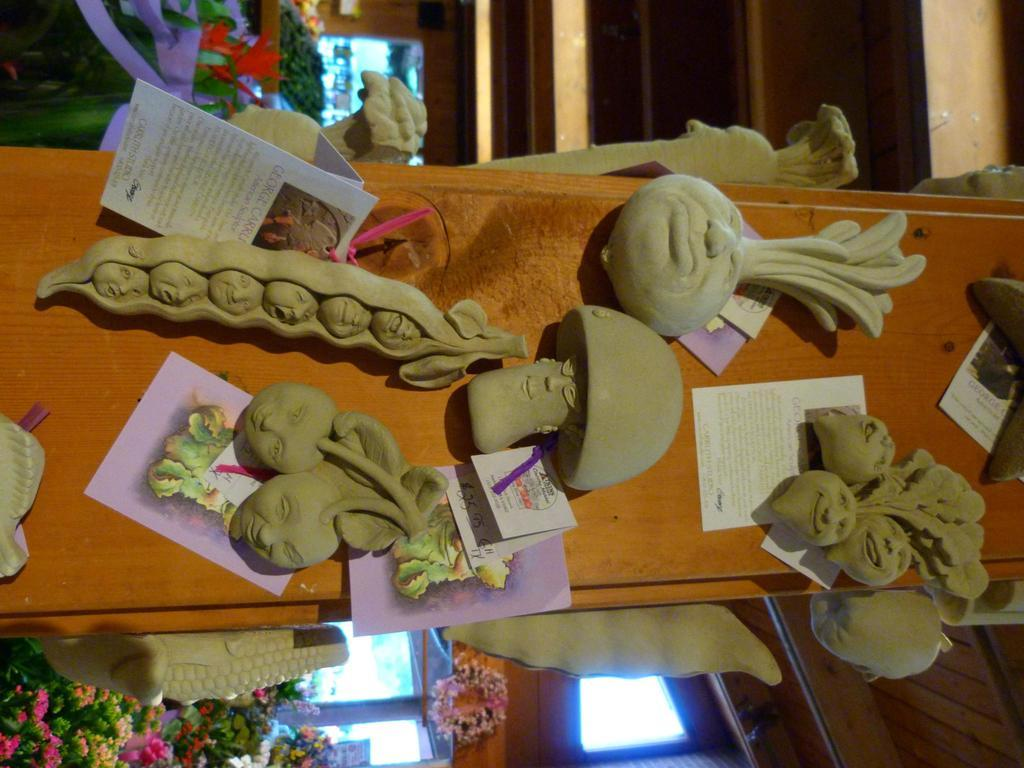What is the main focus of the image? The main focus of the image is the depictions of persons in the center. Can you describe the plants at the bottom of the image? Yes, there are plants at the bottom of the image. How does the image control the wish for a vacation? The image does not control the wish for a vacation, as it is a static image and cannot influence desires or emotions. 